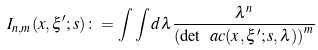Convert formula to latex. <formula><loc_0><loc_0><loc_500><loc_500>I _ { n , m } ( x , \xi ^ { \prime } ; s ) \colon = \int \int d { \lambda } \frac { \lambda ^ { n } } { \left ( \det \ a c ( x , \xi ^ { \prime } ; s , \lambda ) \right ) ^ { m } }</formula> 